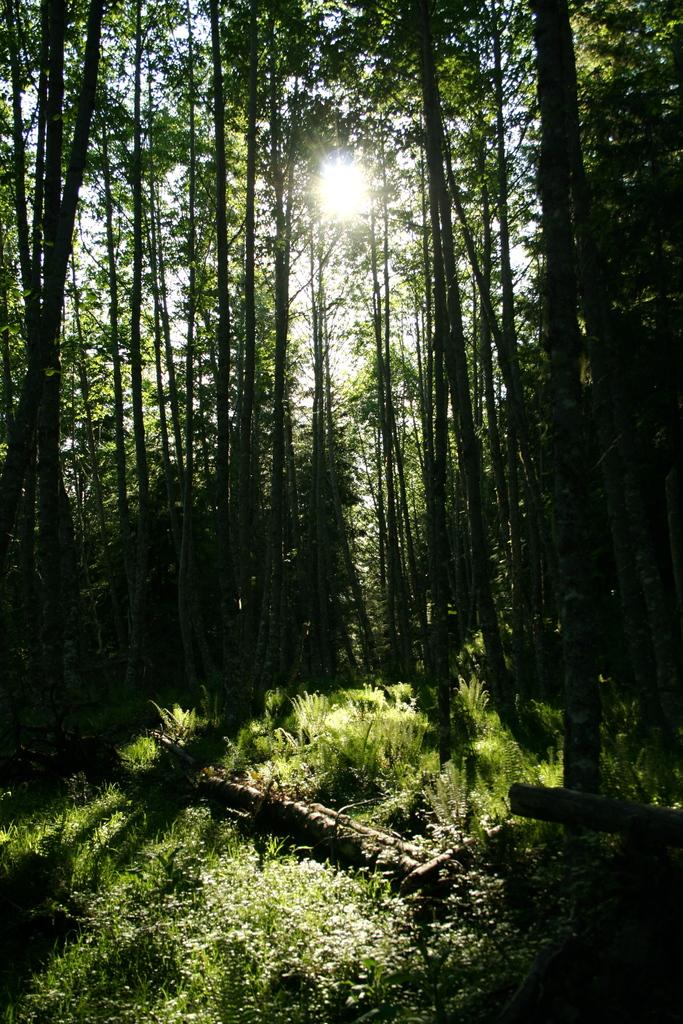What natural phenomenon is depicted in the image? There is a sunrise in the image. What type of vegetation can be seen in the image? There are trees in the image. What is the ground covered with in the image? There is grass visible in the image. What type of detail can be seen on the wrist of the person in the image? There is no person present in the image, so it is not possible to determine any details about their wrist. 